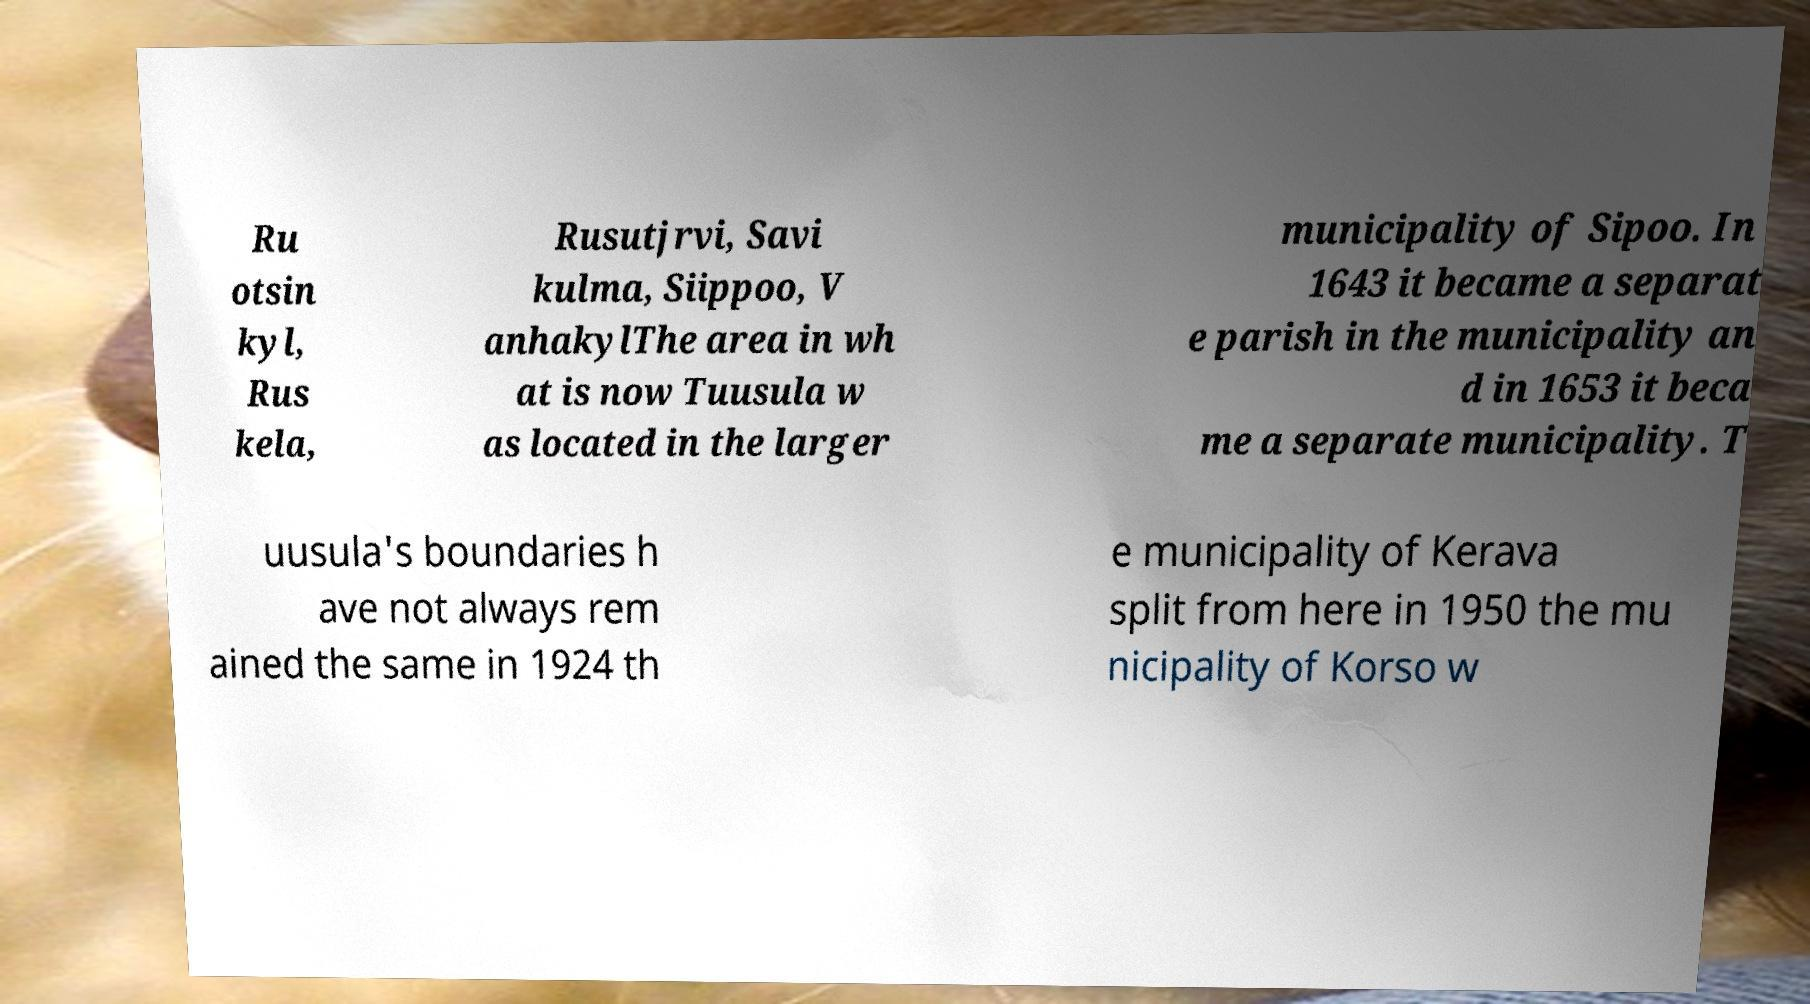Can you read and provide the text displayed in the image?This photo seems to have some interesting text. Can you extract and type it out for me? Ru otsin kyl, Rus kela, Rusutjrvi, Savi kulma, Siippoo, V anhakylThe area in wh at is now Tuusula w as located in the larger municipality of Sipoo. In 1643 it became a separat e parish in the municipality an d in 1653 it beca me a separate municipality. T uusula's boundaries h ave not always rem ained the same in 1924 th e municipality of Kerava split from here in 1950 the mu nicipality of Korso w 